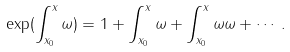Convert formula to latex. <formula><loc_0><loc_0><loc_500><loc_500>\exp ( \int _ { x _ { 0 } } ^ { x } \omega ) = 1 + \int _ { x _ { 0 } } ^ { x } \omega + \int _ { x _ { 0 } } ^ { x } \omega \omega + \cdots .</formula> 